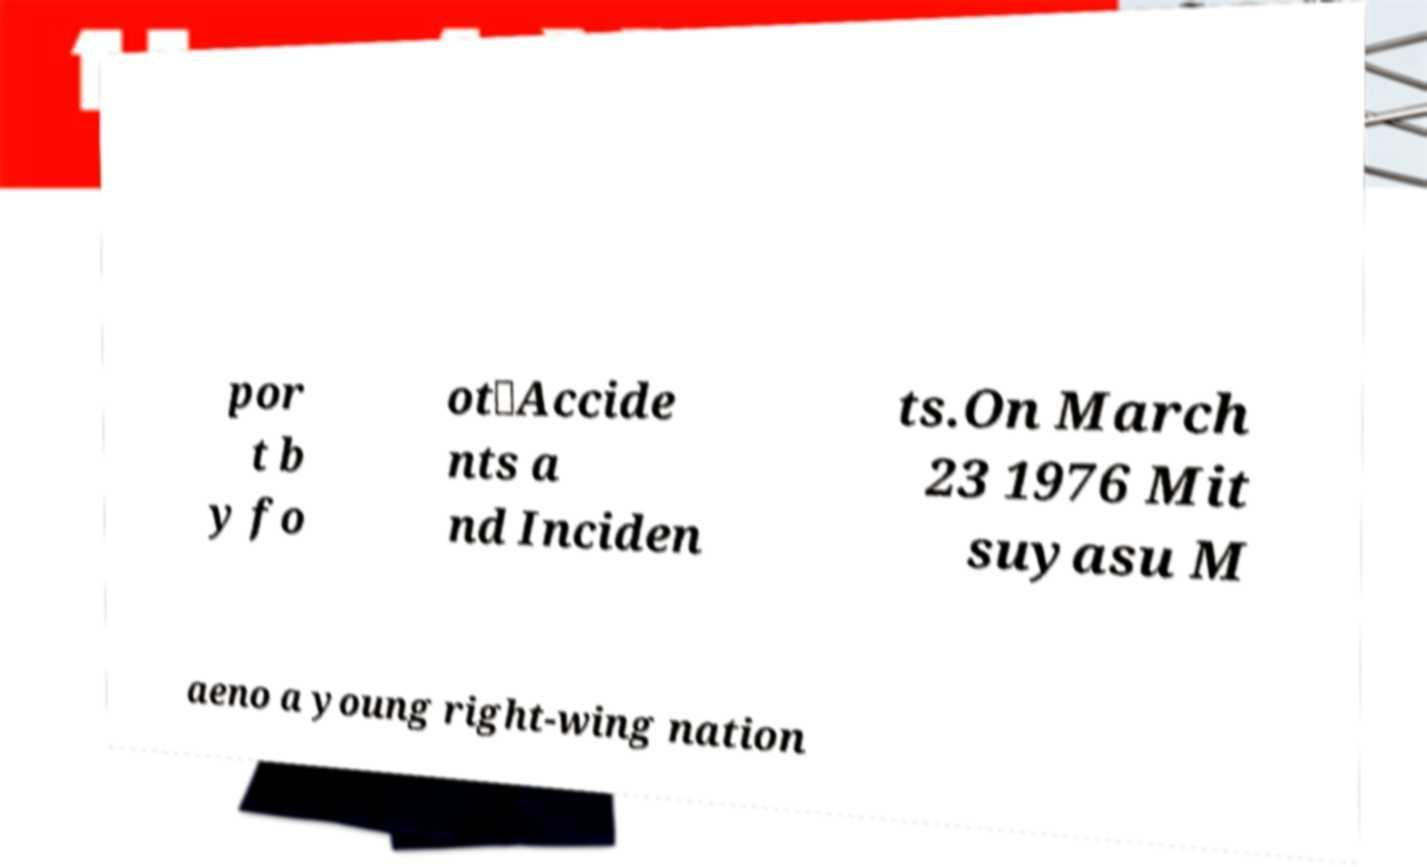What messages or text are displayed in this image? I need them in a readable, typed format. por t b y fo ot．Accide nts a nd Inciden ts.On March 23 1976 Mit suyasu M aeno a young right-wing nation 